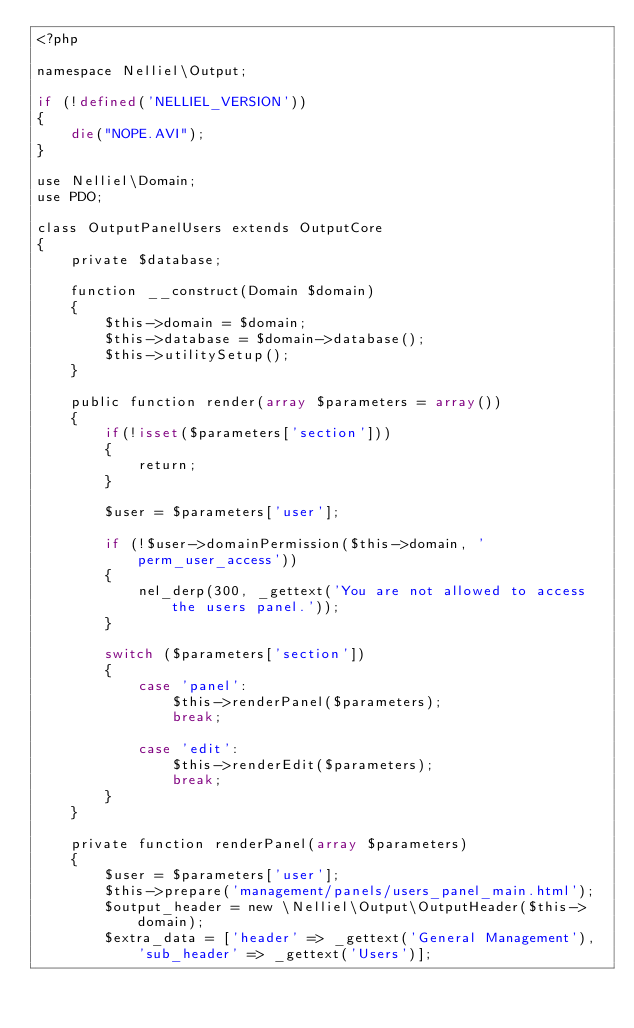Convert code to text. <code><loc_0><loc_0><loc_500><loc_500><_PHP_><?php

namespace Nelliel\Output;

if (!defined('NELLIEL_VERSION'))
{
    die("NOPE.AVI");
}

use Nelliel\Domain;
use PDO;

class OutputPanelUsers extends OutputCore
{
    private $database;

    function __construct(Domain $domain)
    {
        $this->domain = $domain;
        $this->database = $domain->database();
        $this->utilitySetup();
    }

    public function render(array $parameters = array())
    {
        if(!isset($parameters['section']))
        {
            return;
        }

        $user = $parameters['user'];

        if (!$user->domainPermission($this->domain, 'perm_user_access'))
        {
            nel_derp(300, _gettext('You are not allowed to access the users panel.'));
        }

        switch ($parameters['section'])
        {
            case 'panel':
                $this->renderPanel($parameters);
                break;

            case 'edit':
                $this->renderEdit($parameters);
                break;
        }
    }

    private function renderPanel(array $parameters)
    {
        $user = $parameters['user'];
        $this->prepare('management/panels/users_panel_main.html');
        $output_header = new \Nelliel\Output\OutputHeader($this->domain);
        $extra_data = ['header' => _gettext('General Management'), 'sub_header' => _gettext('Users')];</code> 